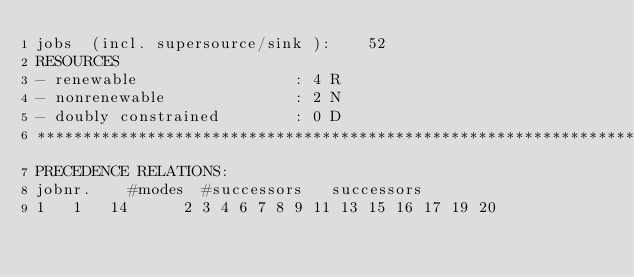Convert code to text. <code><loc_0><loc_0><loc_500><loc_500><_ObjectiveC_>jobs  (incl. supersource/sink ):	52
RESOURCES
- renewable                 : 4 R
- nonrenewable              : 2 N
- doubly constrained        : 0 D
************************************************************************
PRECEDENCE RELATIONS:
jobnr.    #modes  #successors   successors
1	1	14		2 3 4 6 7 8 9 11 13 15 16 17 19 20 </code> 